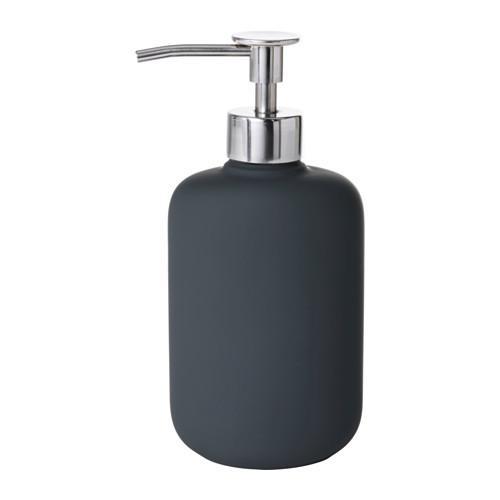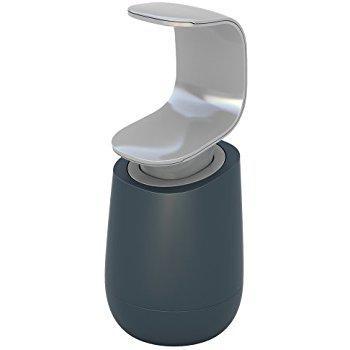The first image is the image on the left, the second image is the image on the right. Assess this claim about the two images: "Someone is using the dispenser in one of the images.". Correct or not? Answer yes or no. No. 